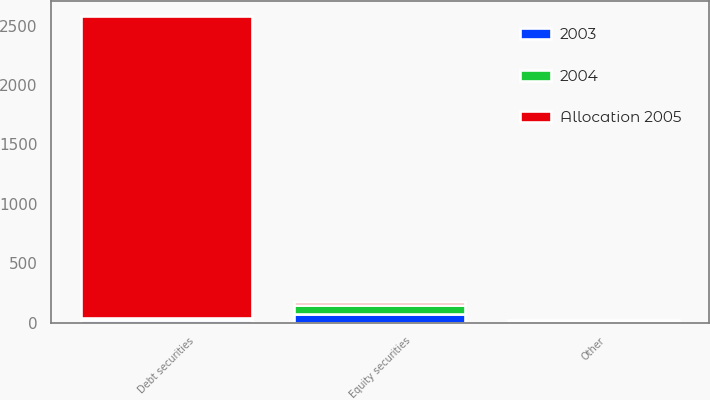<chart> <loc_0><loc_0><loc_500><loc_500><stacked_bar_chart><ecel><fcel>Equity securities<fcel>Debt securities<fcel>Other<nl><fcel>2003<fcel>76<fcel>23<fcel>1<nl><fcel>2004<fcel>75<fcel>19<fcel>6<nl><fcel>Allocation 2005<fcel>21<fcel>2540<fcel>15<nl></chart> 